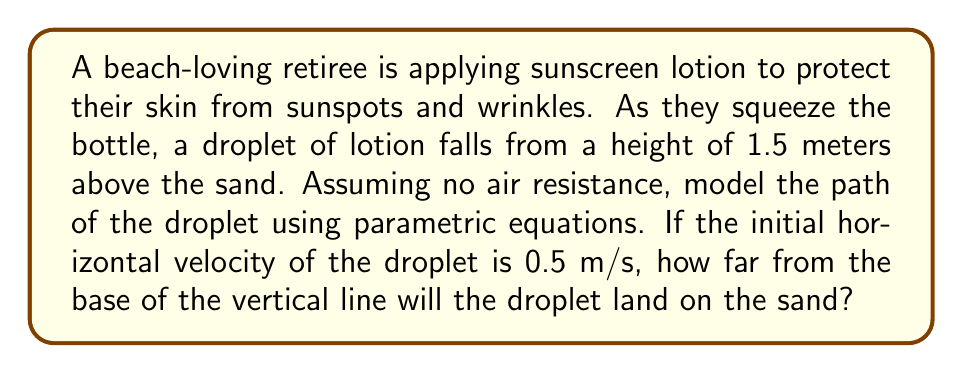Can you answer this question? Let's approach this step-by-step:

1) First, we need to set up our parametric equations. For a projectile motion, we have:

   $$x(t) = x_0 + v_0\cos(\theta)t$$
   $$y(t) = y_0 + v_0\sin(\theta)t - \frac{1}{2}gt^2$$

   Where:
   - $x_0$ and $y_0$ are initial positions
   - $v_0$ is initial velocity
   - $\theta$ is the angle of launch
   - $g$ is acceleration due to gravity (9.8 m/s²)
   - $t$ is time

2) In this case:
   - $x_0 = 0$ (we can choose the starting point as our origin)
   - $y_0 = 1.5$ m (initial height)
   - $v_0\cos(\theta) = 0.5$ m/s (given horizontal velocity)
   - $v_0\sin(\theta) = 0$ (no initial vertical velocity)

3) Our equations simplify to:

   $$x(t) = 0.5t$$
   $$y(t) = 1.5 - 4.9t^2$$

4) To find where the droplet lands, we need to find $t$ when $y(t) = 0$:

   $$0 = 1.5 - 4.9t^2$$
   $$4.9t^2 = 1.5$$
   $$t^2 = \frac{1.5}{4.9} \approx 0.3061$$
   $$t \approx 0.5533\text{ seconds}$$

5) Now we can find $x$ when the droplet lands by plugging this $t$ back into $x(t)$:

   $$x(0.5533) = 0.5 * 0.5533 \approx 0.2767\text{ meters}$$

Therefore, the droplet will land approximately 0.2767 meters from the base of the vertical line.
Answer: The droplet will land approximately 0.2767 meters from the base of the vertical line. 